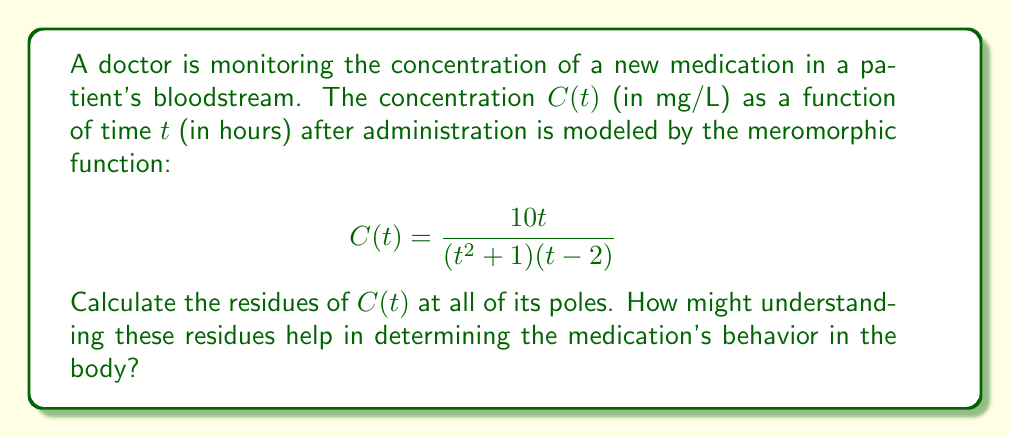Can you answer this question? To calculate the residues of $C(t)$, we need to identify its poles and determine their order. The function $C(t)$ has three poles:

1. $t = i$ (simple pole)
2. $t = -i$ (simple pole)
3. $t = 2$ (simple pole)

For simple poles, we can use the formula:
$$\text{Res}(C, a) = \lim_{t \to a} (t-a)C(t)$$

1. Residue at $t = i$:
   $$\begin{aligned}
   \text{Res}(C, i) &= \lim_{t \to i} (t-i)\frac{10t}{(t^2 + 1)(t - 2)} \\
   &= \lim_{t \to i} \frac{10t(t-i)}{(t+i)(t-i)(t - 2)} \\
   &= \frac{10i(i-i)}{(i+i)(i-2)} = \frac{0}{2i(-2+i)} = 0
   \end{aligned}$$

2. Residue at $t = -i$:
   $$\begin{aligned}
   \text{Res}(C, -i) &= \lim_{t \to -i} (t+i)\frac{10t}{(t^2 + 1)(t - 2)} \\
   &= \lim_{t \to -i} \frac{10t(t+i)}{(t-i)(t+i)(t - 2)} \\
   &= \frac{10(-i)(-i+i)}{(-i-i)(-i-2)} = \frac{0}{-2i(-2-i)} = 0
   \end{aligned}$$

3. Residue at $t = 2$:
   $$\begin{aligned}
   \text{Res}(C, 2) &= \lim_{t \to 2} (t-2)\frac{10t}{(t^2 + 1)(t - 2)} \\
   &= \lim_{t \to 2} \frac{10t}{t^2 + 1} \\
   &= \frac{20}{5} = 4
   \end{aligned}$$

Understanding these residues can help determine the medication's behavior in the body:

1. The residues at $t = i$ and $t = -i$ being zero indicate that these complex poles don't contribute significantly to the long-term behavior of the drug concentration.

2. The non-zero residue at $t = 2$ suggests that this pole has a more substantial impact on the drug's concentration over time. It may indicate a critical point in the drug's elimination process, possibly related to its half-life or clearance rate.

3. The magnitude of the residue at $t = 2$ (which is 4) could be interpreted as a measure of the drug's persistence in the bloodstream around the 2-hour mark after administration.

This analysis can help healthcare providers optimize dosing schedules and understand the drug's pharmacokinetics, which is particularly valuable for older patients who may have altered drug metabolism.
Answer: The residues of $C(t)$ are:
$$\text{Res}(C, i) = 0$$
$$\text{Res}(C, -i) = 0$$
$$\text{Res}(C, 2) = 4$$ 